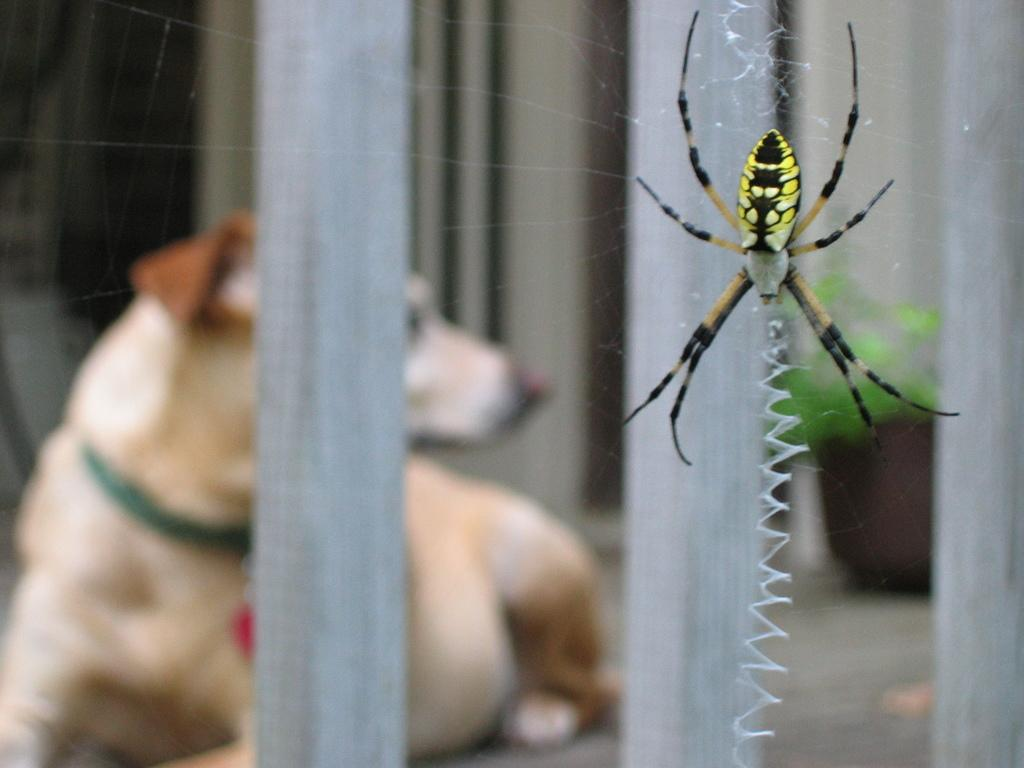What is on the glass in the image? There is an insect on the glass in the image. What can be seen beyond the glass? A dog and a plant are visible through the glass. What is the chance of winning a lottery in the image? There is no information about a lottery or winning chances in the image. 